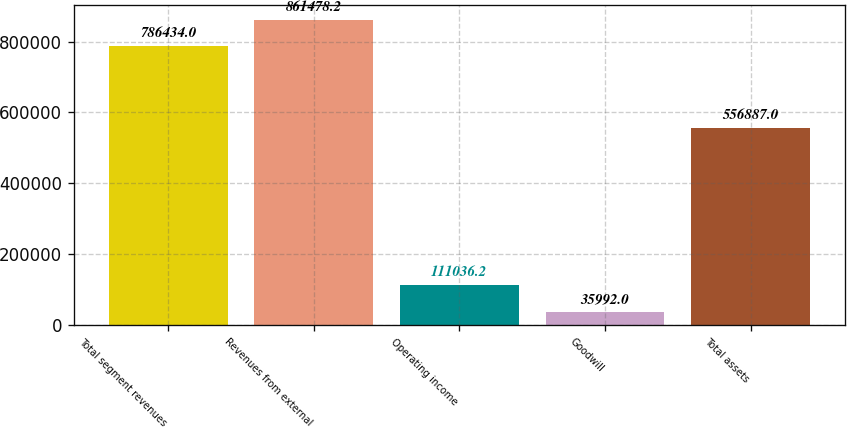<chart> <loc_0><loc_0><loc_500><loc_500><bar_chart><fcel>Total segment revenues<fcel>Revenues from external<fcel>Operating income<fcel>Goodwill<fcel>Total assets<nl><fcel>786434<fcel>861478<fcel>111036<fcel>35992<fcel>556887<nl></chart> 